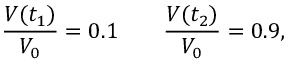<formula> <loc_0><loc_0><loc_500><loc_500>{ \frac { V ( t _ { 1 } ) } { V _ { 0 } } } = 0 . 1 \quad { \frac { V ( t _ { 2 } ) } { V _ { 0 } } } = 0 . 9 ,</formula> 